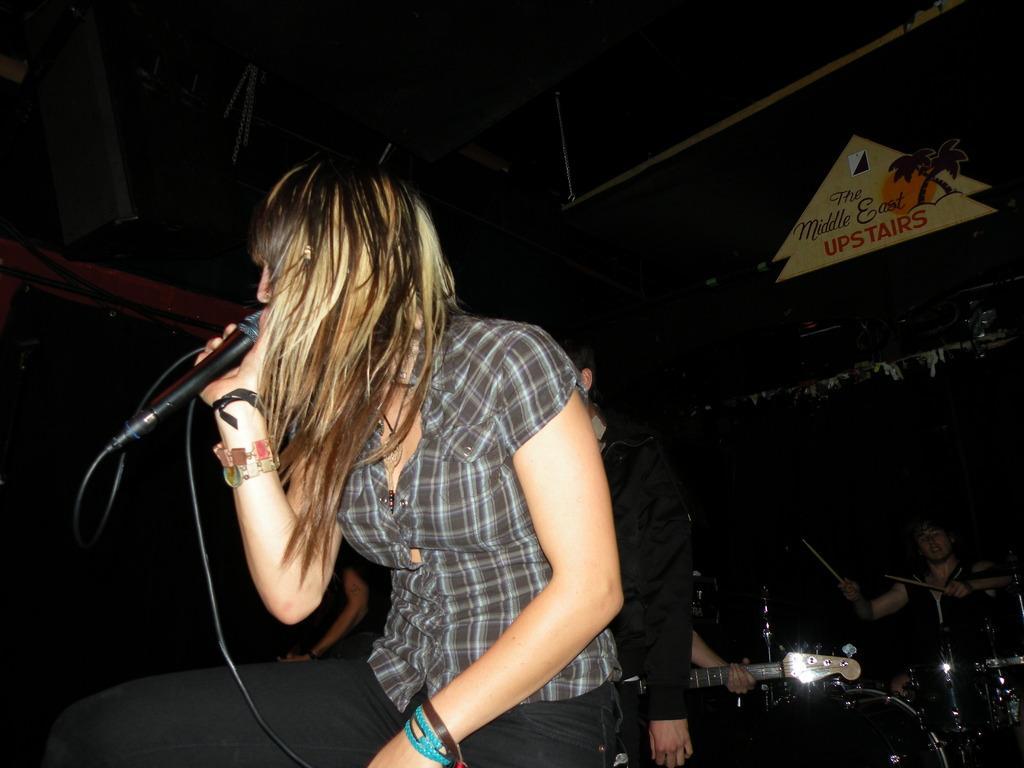Can you describe this image briefly? In this image we can see a woman is sitting and singing, and holding a micro phone in the hands, and at back here is the person playing the musical drums. 